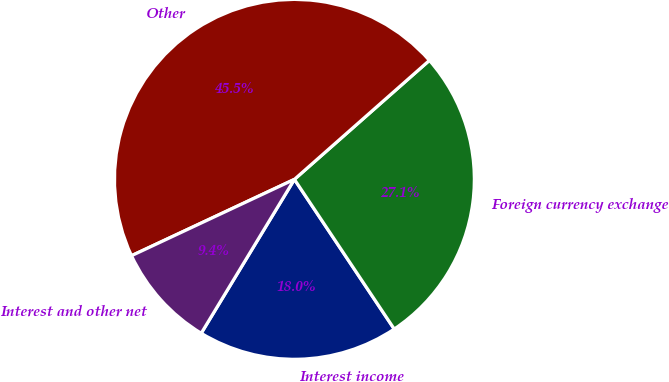Convert chart to OTSL. <chart><loc_0><loc_0><loc_500><loc_500><pie_chart><fcel>Interest income<fcel>Foreign currency exchange<fcel>Other<fcel>Interest and other net<nl><fcel>18.03%<fcel>27.14%<fcel>45.48%<fcel>9.36%<nl></chart> 